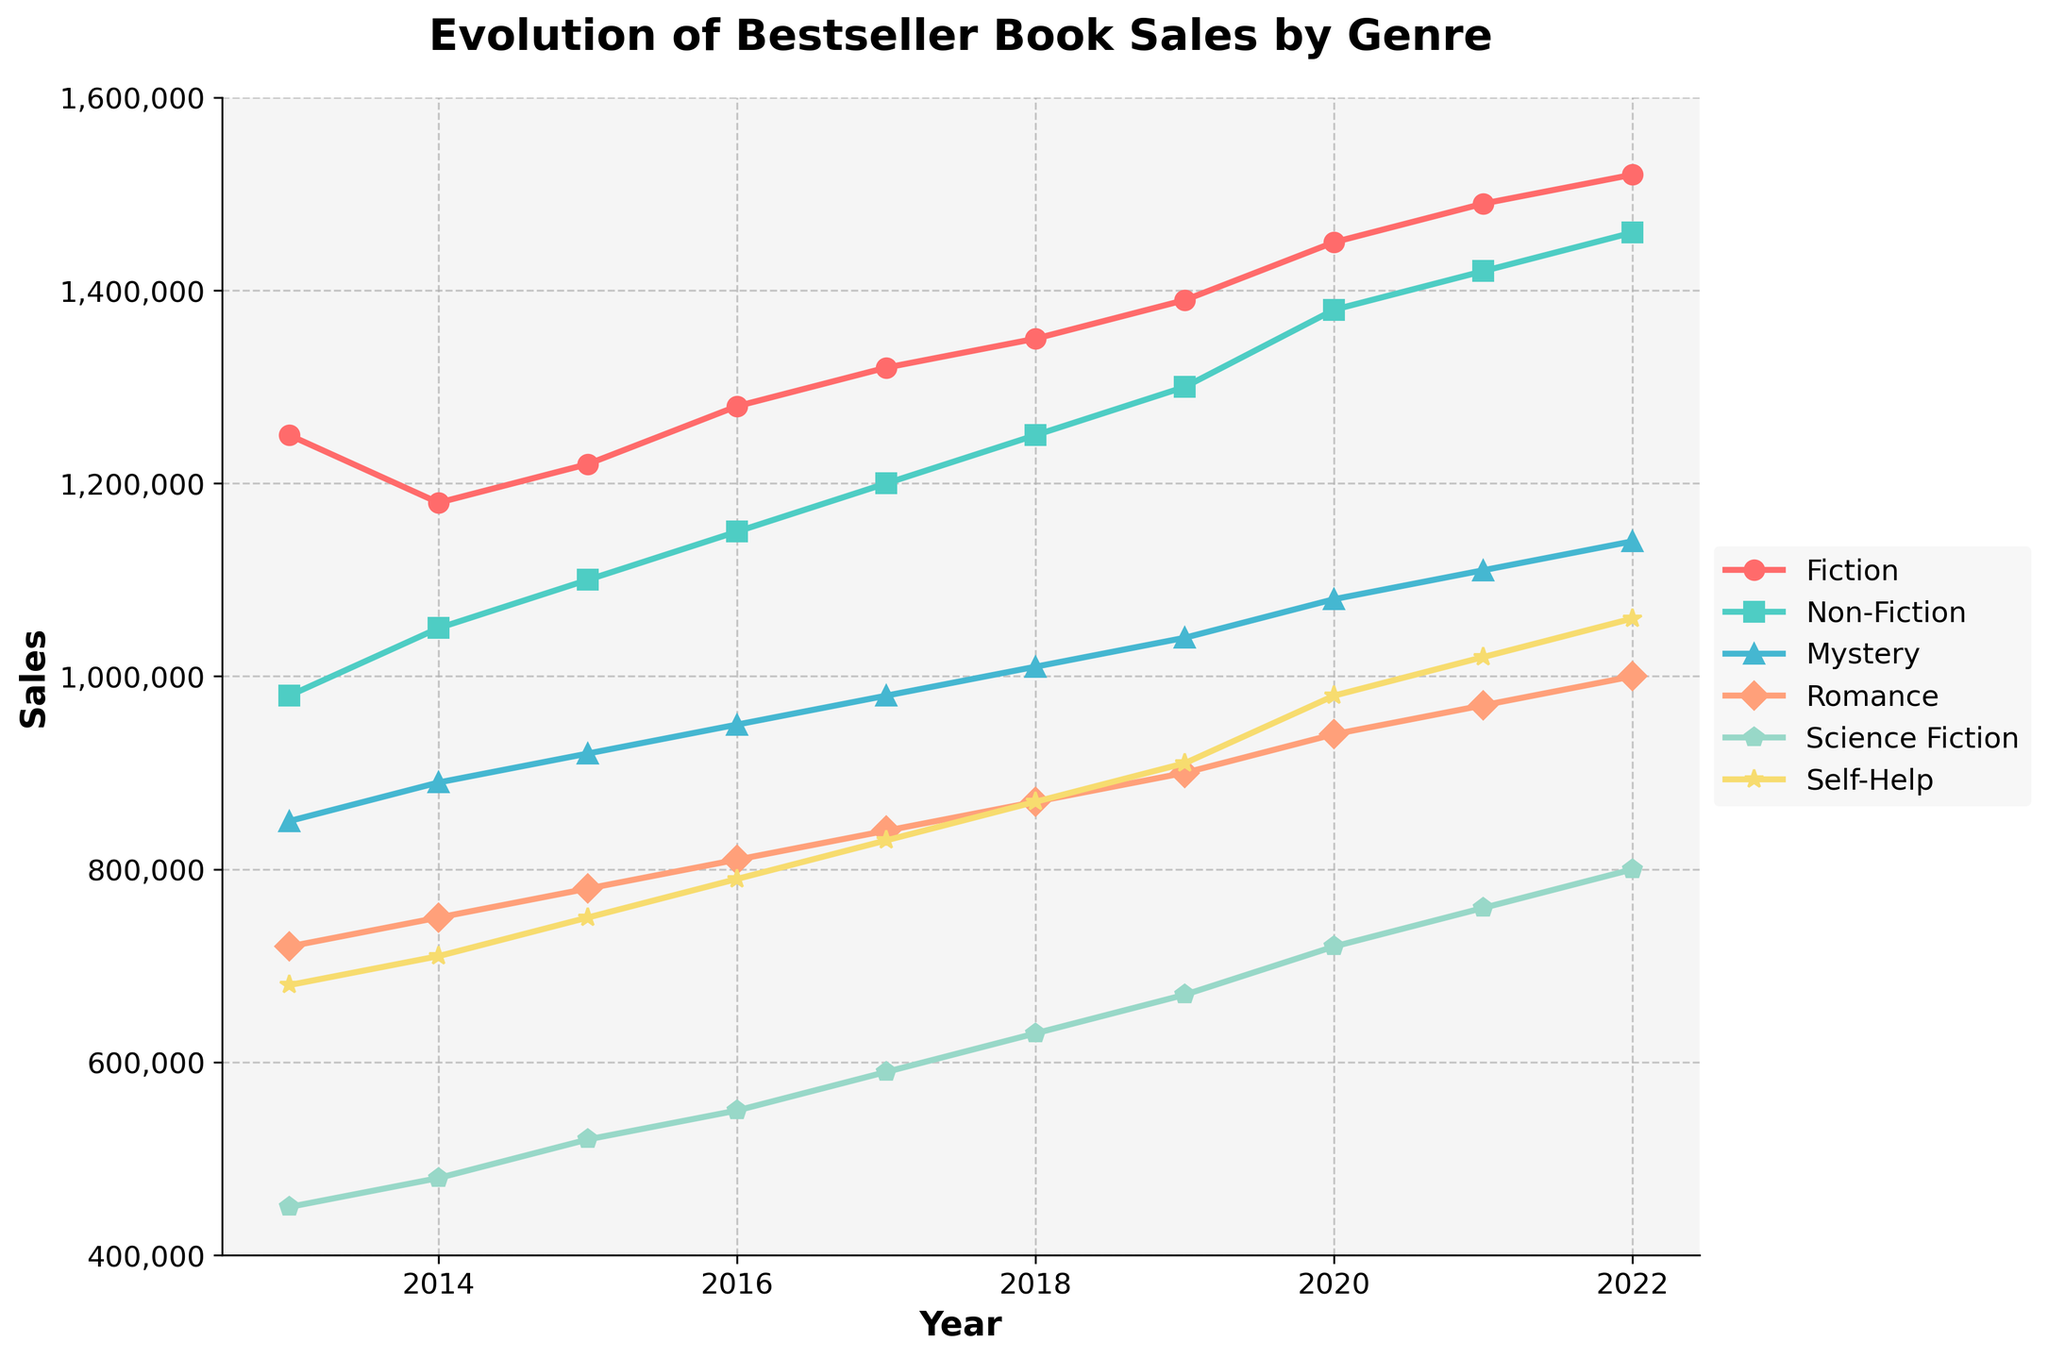Which genre had the highest sales in 2022? By looking at the plotted lines for each genre, identify the one that reaches the highest value on the y-axis in the year 2022.
Answer: Fiction Which genre saw the most consistent growth over the decade? Observe the trend lines for each genre; the most consistent growth will appear as the smoothest, steadily ascending line with no major dips.
Answer: Fiction In which year did Non-Fiction sales surpass Fiction sales by the smallest margin? Find the year where the difference between the Non-Fiction and Fiction lines is the smallest. This requires comparing the vertical distances on the plot for each year.
Answer: 2014 What was the combined sales figure for Mystery and Romance in 2019? Locate the sales figures for Mystery and Romance in 2019 from the plot, and then sum these two values. Mystery: 1,040,000, Romance: 900,000. Combined: 1,040,000 + 900,000 = 1,940,000
Answer: 1,940,000 By how much did Self-Help sales increase from 2013 to 2022? Identify the values for Self-Help in 2013 and 2022 from the plot, and then calculate the difference. 2022: 1,060,000, 2013: 680,000. Increase: 1,060,000 - 680,000 = 380,000
Answer: 380,000 Which genre had the smallest increase in sales between 2016 and 2017? Calculate the difference in sales for each genre between the years 2016 and 2017, and identify which genre has the smallest difference.
Answer: Science Fiction What is the average annual sales for Science Fiction over the decade? Sum the annual sales figures for Science Fiction from 2013 to 2022, and then divide by the number of years (10). Sum: 450,000 + 480,000 + 520,000 + 550,000 + 590,000 + 630,000 + 670,000 + 720,000 + 760,000 + 800,000 = 6,170,000. Average: 6,170,000 / 10 = 617,000
Answer: 617,000 Did Romance or Self-Help have higher sales in 2020? Compare the height (value) of the Romance line versus the Self-Help line for the year 2020.
Answer: Self-Help What is the overall trend for Fiction sales over the past decade? Observe the line representing Fiction sales from left (2013) to right (2022). Determine if it is mostly upward, downward, or flat.
Answer: Upward 